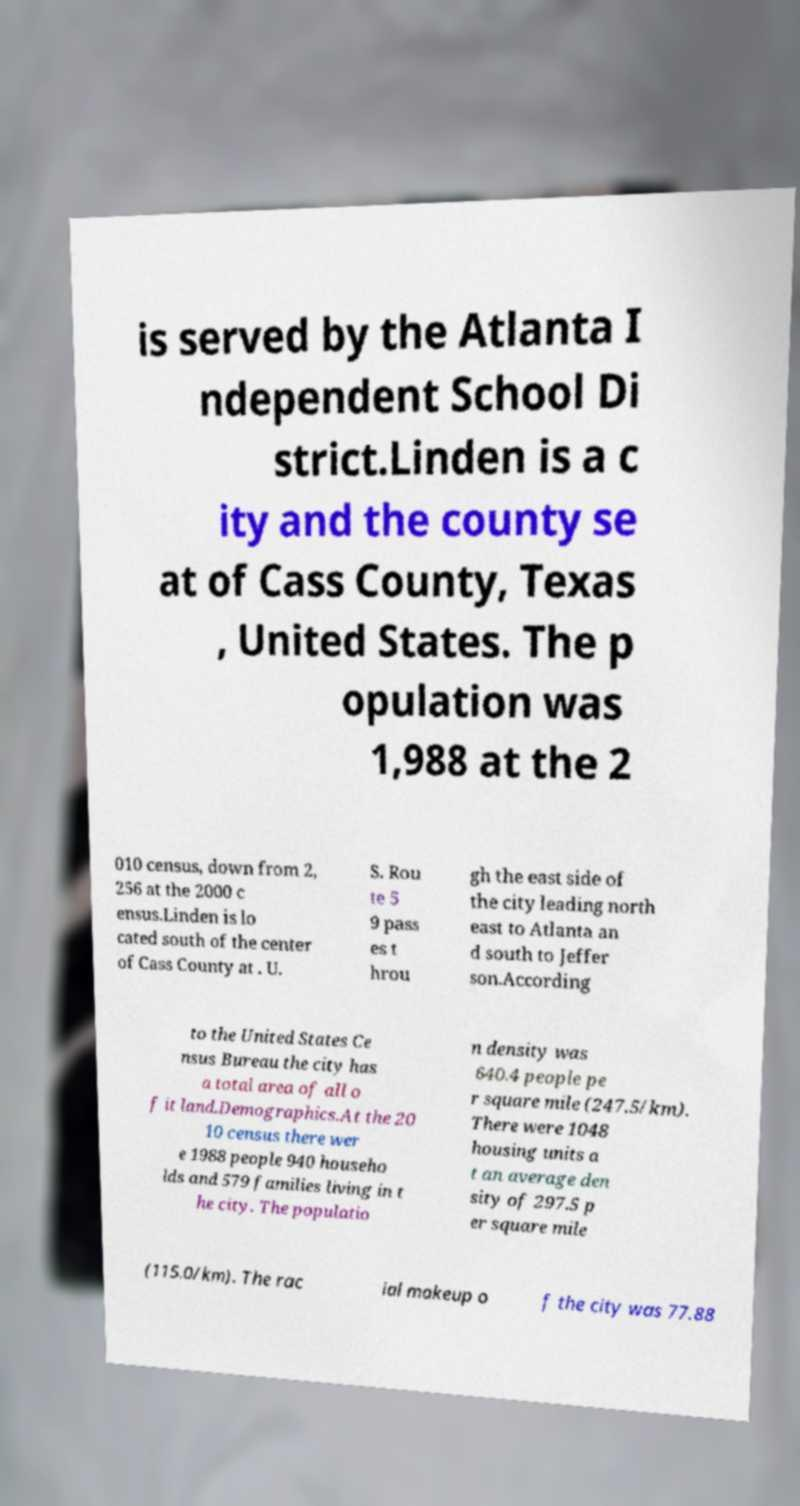Could you extract and type out the text from this image? is served by the Atlanta I ndependent School Di strict.Linden is a c ity and the county se at of Cass County, Texas , United States. The p opulation was 1,988 at the 2 010 census, down from 2, 256 at the 2000 c ensus.Linden is lo cated south of the center of Cass County at . U. S. Rou te 5 9 pass es t hrou gh the east side of the city leading north east to Atlanta an d south to Jeffer son.According to the United States Ce nsus Bureau the city has a total area of all o f it land.Demographics.At the 20 10 census there wer e 1988 people 940 househo lds and 579 families living in t he city. The populatio n density was 640.4 people pe r square mile (247.5/km). There were 1048 housing units a t an average den sity of 297.5 p er square mile (115.0/km). The rac ial makeup o f the city was 77.88 